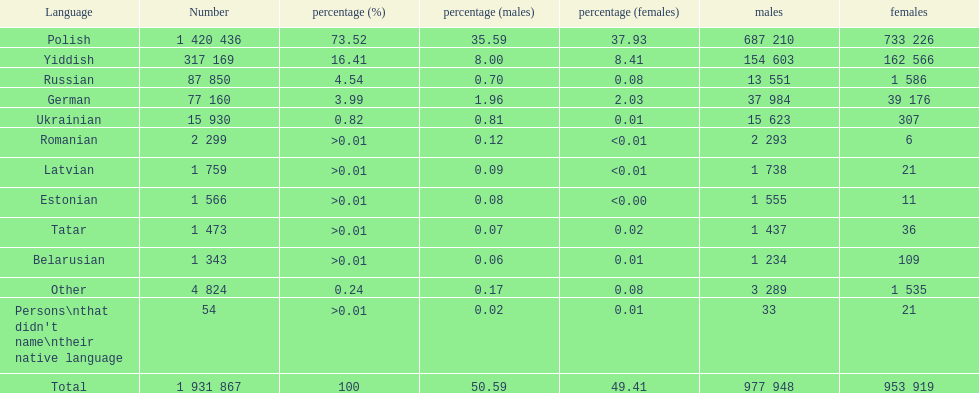Parse the full table in json format. {'header': ['Language', 'Number', 'percentage (%)', 'percentage (males)', 'percentage (females)', 'males', 'females'], 'rows': [['Polish', '1 420 436', '73.52', '35.59', '37.93', '687 210', '733 226'], ['Yiddish', '317 169', '16.41', '8.00', '8.41', '154 603', '162 566'], ['Russian', '87 850', '4.54', '0.70', '0.08', '13 551', '1 586'], ['German', '77 160', '3.99', '1.96', '2.03', '37 984', '39 176'], ['Ukrainian', '15 930', '0.82', '0.81', '0.01', '15 623', '307'], ['Romanian', '2 299', '>0.01', '0.12', '<0.01', '2 293', '6'], ['Latvian', '1 759', '>0.01', '0.09', '<0.01', '1 738', '21'], ['Estonian', '1 566', '>0.01', '0.08', '<0.00', '1 555', '11'], ['Tatar', '1 473', '>0.01', '0.07', '0.02', '1 437', '36'], ['Belarusian', '1 343', '>0.01', '0.06', '0.01', '1 234', '109'], ['Other', '4 824', '0.24', '0.17', '0.08', '3 289', '1 535'], ["Persons\\nthat didn't name\\ntheir native language", '54', '>0.01', '0.02', '0.01', '33', '21'], ['Total', '1 931 867', '100', '50.59', '49.41', '977 948', '953 919']]} What are all of the languages used in the warsaw governorate? Polish, Yiddish, Russian, German, Ukrainian, Romanian, Latvian, Estonian, Tatar, Belarusian, Other, Persons\nthat didn't name\ntheir native language. Which language was comprised of the least number of female speakers? Romanian. 